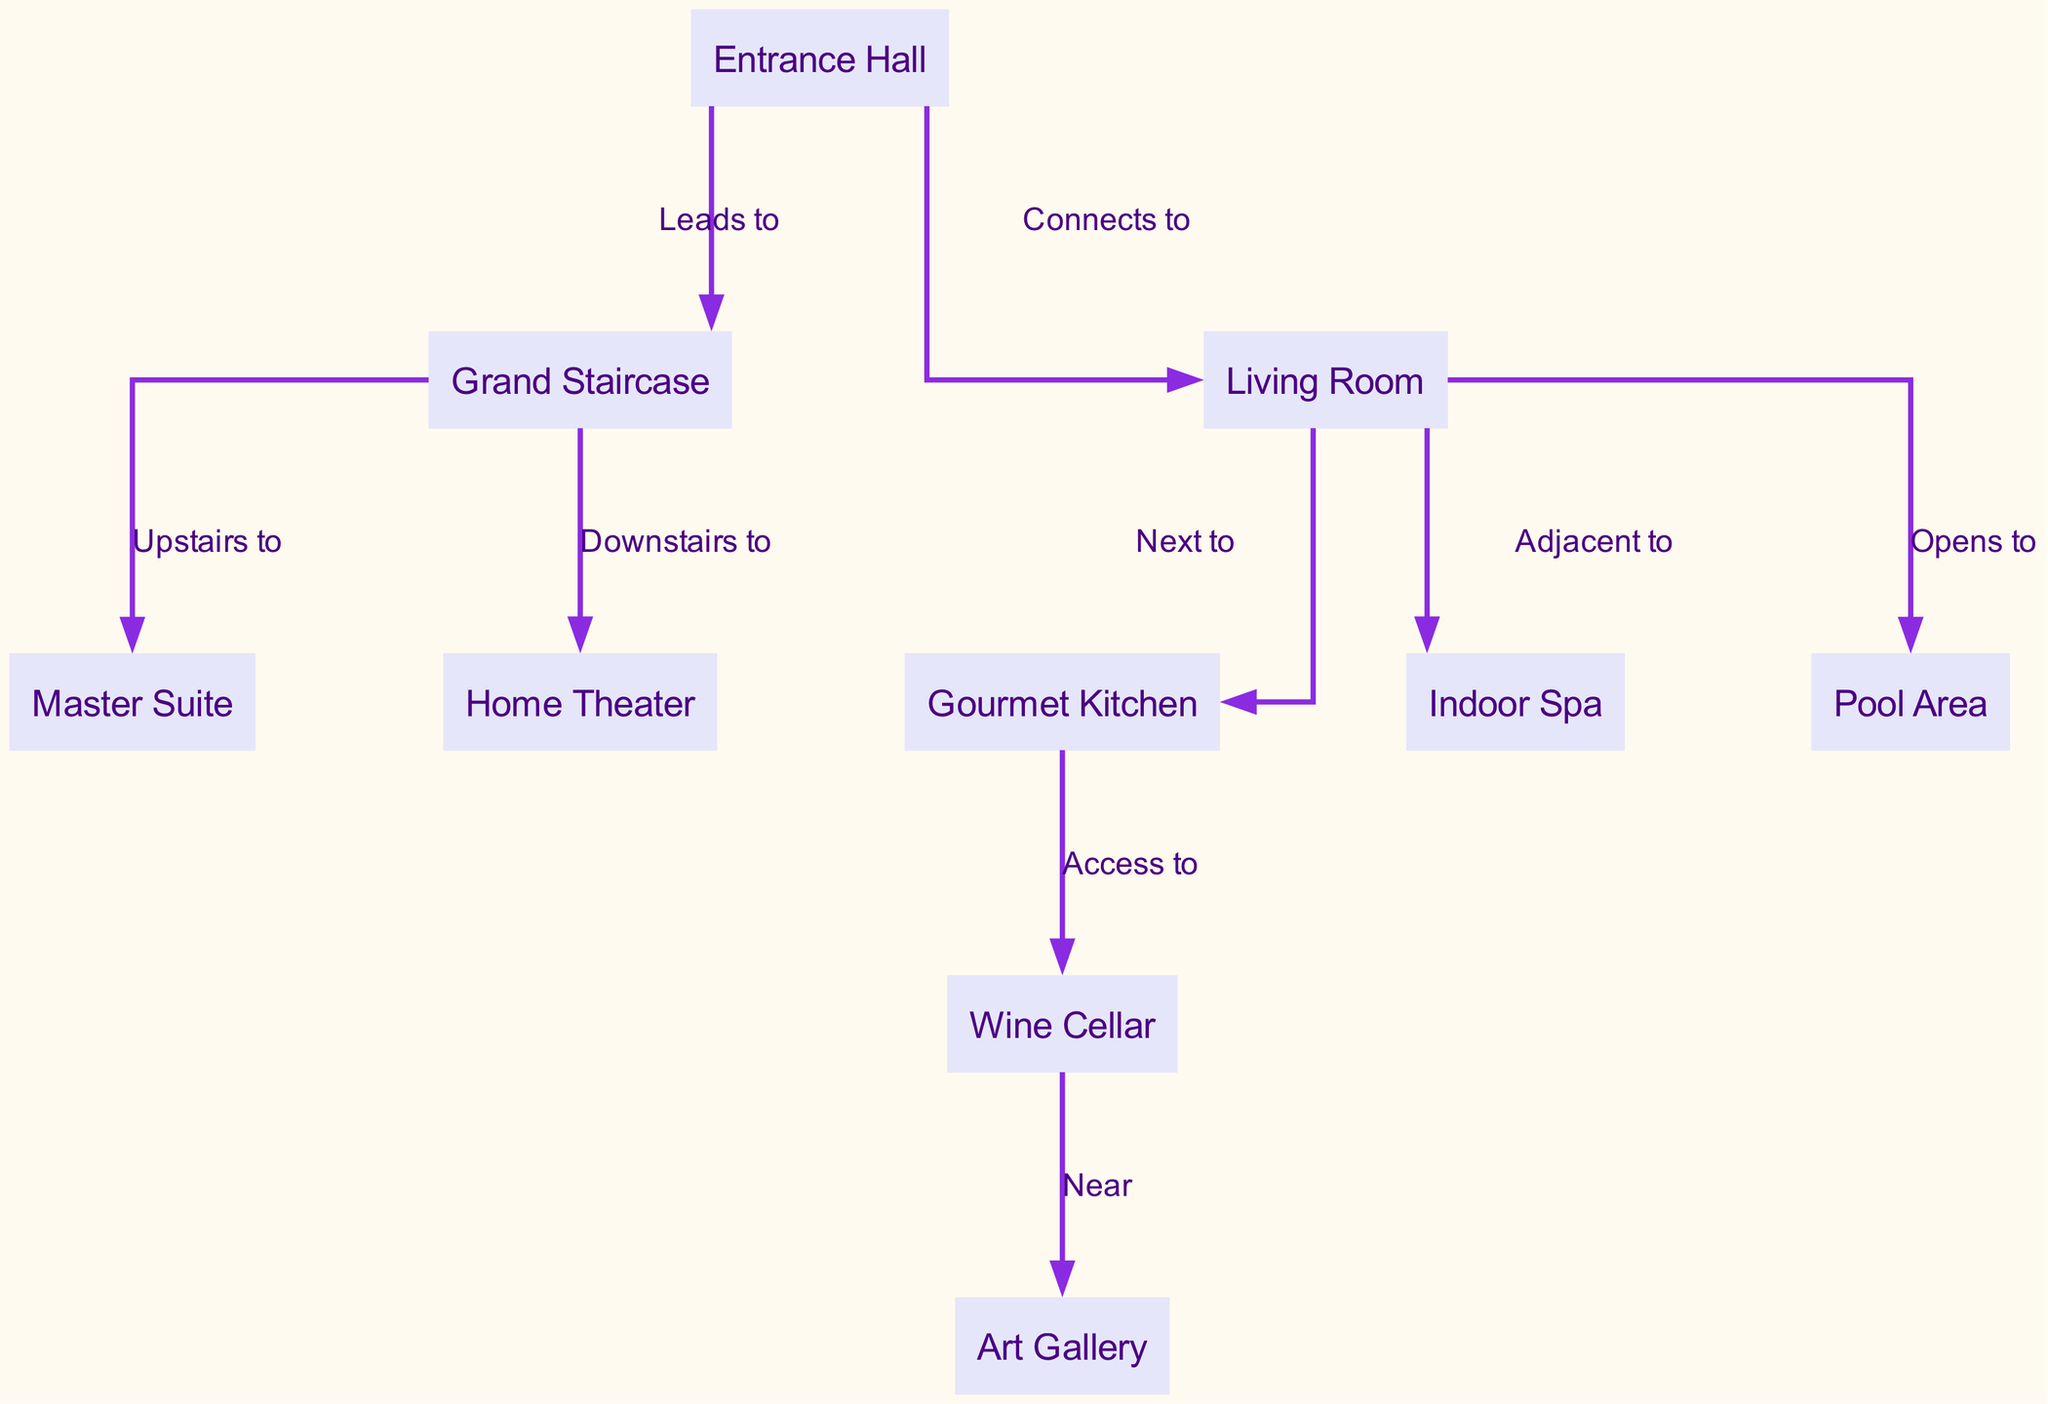What is the first area you enter upon arrival? The diagram labels the "Entrance Hall" as the first area you encounter when entering the mansion, making it the starting point of the layout.
Answer: Entrance Hall How many opulent features are shown in the mansion layout? The diagram indicates that there are seven distinct opulent features, namely the Indoor Spa, Wine Cellar, Art Gallery, Gourmet Kitchen, Living Room, Master Suite, and Home Theater. Counting these nodes provides the total.
Answer: Seven Which room connects directly to the Living Room? The diagram illustrates that the Living Room connects directly to the Gourmet Kitchen and also indicates that it is adjacent to the Indoor Spa, showcasing its central location in relation to these areas.
Answer: Gourmet Kitchen Where does the Grand Staircase lead to? The diagram shows two pathways: one leads upstairs to the Master Suite and the other leads downstairs to the Home Theater, establishing connections through vertical movement in the mansion.
Answer: Master Suite and Home Theater How many rooms are located adjacent to the Living Room? The diagram shows that the Living Room is adjacent to two rooms: the Indoor Spa and the Gourmet Kitchen. This adjacency illustrates how spaces are designed to flow into each other.
Answer: Two What is the relationship between the Wine Cellar and the Art Gallery? The diagram specifies that the Wine Cellar is "Near" the Art Gallery, indicating that these two luxurious areas are close to one another, likely enhancing the ambiance of both.
Answer: Near Which area opens to the pool? According to the diagram, the Living Room "Opens to" the Pool Area, signifying a direct connection that likely enhances the outdoor living experience in the mansion.
Answer: Pool Area How are the Kitchen and Wine Cellar related? The diagram depicts that the Gourmet Kitchen has "Access to" the Wine Cellar, which suggests that the design allows for easy transportation of goods between these two culinary-focused spaces.
Answer: Access to What is the main access point to the upper level? The diagram highlights the Grand Staircase as the main access point, establishing its importance in navigating between the different levels of the mansion's layout.
Answer: Grand Staircase 